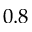<formula> <loc_0><loc_0><loc_500><loc_500>0 . 8</formula> 